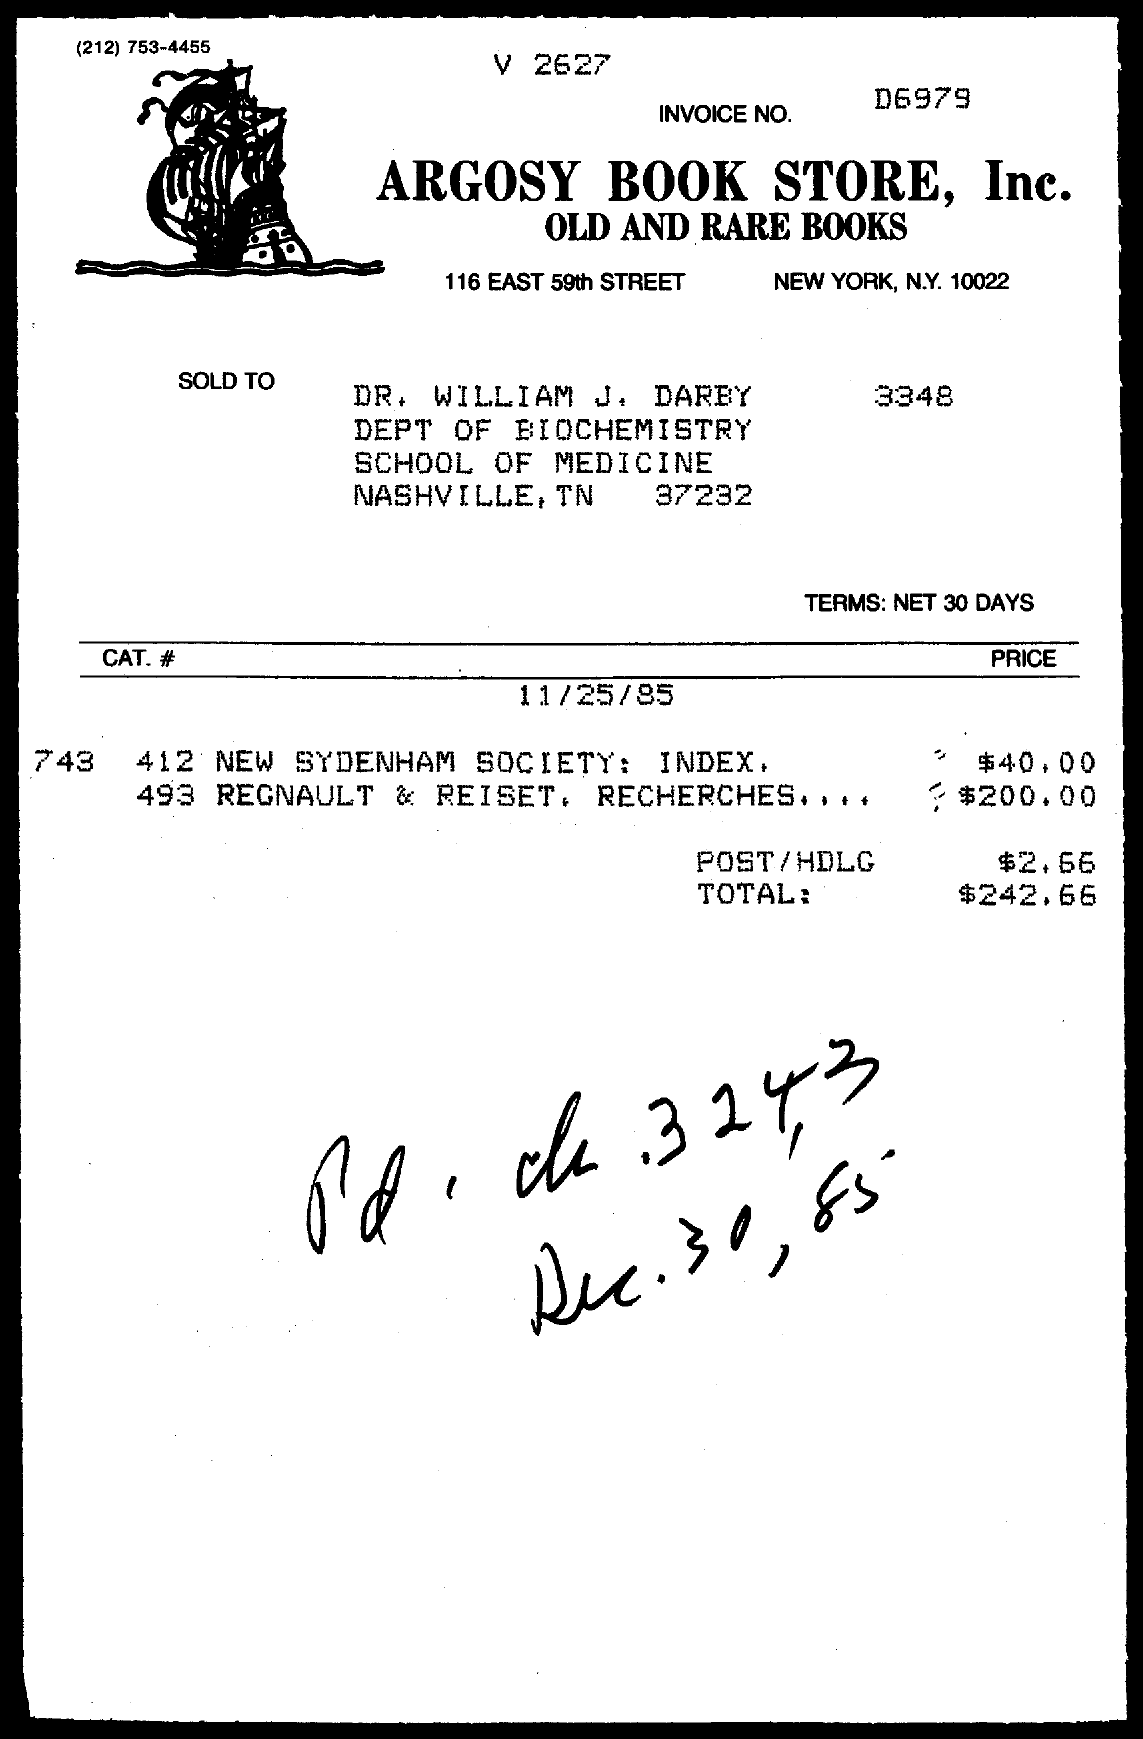List a handful of essential elements in this visual. The handwritten date at the bottom of the page is "December 30, 1985. The Invoice No. is d6979... 